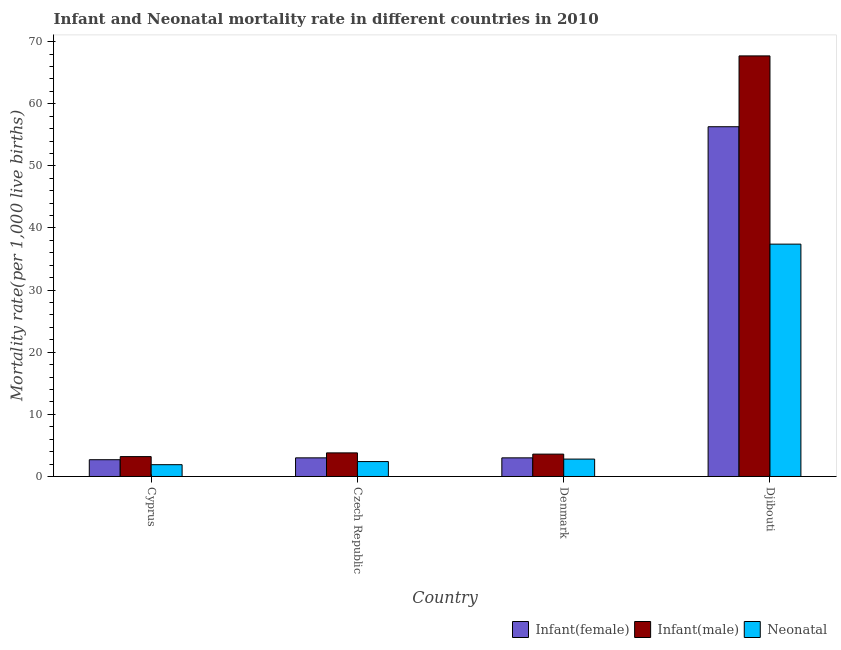How many different coloured bars are there?
Your answer should be very brief. 3. How many bars are there on the 3rd tick from the left?
Give a very brief answer. 3. How many bars are there on the 2nd tick from the right?
Offer a very short reply. 3. What is the label of the 1st group of bars from the left?
Provide a succinct answer. Cyprus. In how many cases, is the number of bars for a given country not equal to the number of legend labels?
Give a very brief answer. 0. What is the neonatal mortality rate in Djibouti?
Ensure brevity in your answer.  37.4. Across all countries, what is the maximum infant mortality rate(female)?
Offer a terse response. 56.3. Across all countries, what is the minimum infant mortality rate(female)?
Your answer should be compact. 2.7. In which country was the infant mortality rate(female) maximum?
Offer a very short reply. Djibouti. In which country was the infant mortality rate(female) minimum?
Your answer should be very brief. Cyprus. What is the total neonatal mortality rate in the graph?
Offer a terse response. 44.5. What is the difference between the neonatal mortality rate in Cyprus and that in Denmark?
Ensure brevity in your answer.  -0.9. What is the difference between the infant mortality rate(male) in Denmark and the neonatal mortality rate in Czech Republic?
Provide a short and direct response. 1.2. What is the average neonatal mortality rate per country?
Offer a terse response. 11.12. What is the difference between the infant mortality rate(female) and neonatal mortality rate in Djibouti?
Your response must be concise. 18.9. What is the ratio of the infant mortality rate(female) in Cyprus to that in Denmark?
Your answer should be compact. 0.9. Is the neonatal mortality rate in Czech Republic less than that in Denmark?
Offer a terse response. Yes. What is the difference between the highest and the second highest infant mortality rate(female)?
Give a very brief answer. 53.3. What is the difference between the highest and the lowest infant mortality rate(male)?
Your answer should be compact. 64.5. In how many countries, is the infant mortality rate(female) greater than the average infant mortality rate(female) taken over all countries?
Your answer should be compact. 1. What does the 1st bar from the left in Cyprus represents?
Provide a short and direct response. Infant(female). What does the 3rd bar from the right in Cyprus represents?
Your answer should be compact. Infant(female). How many bars are there?
Your answer should be compact. 12. What is the difference between two consecutive major ticks on the Y-axis?
Your response must be concise. 10. Are the values on the major ticks of Y-axis written in scientific E-notation?
Ensure brevity in your answer.  No. Does the graph contain any zero values?
Your answer should be compact. No. Where does the legend appear in the graph?
Your answer should be compact. Bottom right. What is the title of the graph?
Offer a terse response. Infant and Neonatal mortality rate in different countries in 2010. What is the label or title of the Y-axis?
Your answer should be compact. Mortality rate(per 1,0 live births). What is the Mortality rate(per 1,000 live births) of Infant(female) in Cyprus?
Offer a very short reply. 2.7. What is the Mortality rate(per 1,000 live births) in Infant(male) in Czech Republic?
Your answer should be very brief. 3.8. What is the Mortality rate(per 1,000 live births) of Infant(female) in Djibouti?
Keep it short and to the point. 56.3. What is the Mortality rate(per 1,000 live births) in Infant(male) in Djibouti?
Your response must be concise. 67.7. What is the Mortality rate(per 1,000 live births) in Neonatal  in Djibouti?
Keep it short and to the point. 37.4. Across all countries, what is the maximum Mortality rate(per 1,000 live births) in Infant(female)?
Make the answer very short. 56.3. Across all countries, what is the maximum Mortality rate(per 1,000 live births) of Infant(male)?
Make the answer very short. 67.7. Across all countries, what is the maximum Mortality rate(per 1,000 live births) of Neonatal ?
Your answer should be very brief. 37.4. Across all countries, what is the minimum Mortality rate(per 1,000 live births) of Infant(female)?
Provide a short and direct response. 2.7. Across all countries, what is the minimum Mortality rate(per 1,000 live births) of Infant(male)?
Your answer should be very brief. 3.2. Across all countries, what is the minimum Mortality rate(per 1,000 live births) in Neonatal ?
Keep it short and to the point. 1.9. What is the total Mortality rate(per 1,000 live births) in Infant(female) in the graph?
Give a very brief answer. 65. What is the total Mortality rate(per 1,000 live births) in Infant(male) in the graph?
Provide a short and direct response. 78.3. What is the total Mortality rate(per 1,000 live births) in Neonatal  in the graph?
Offer a terse response. 44.5. What is the difference between the Mortality rate(per 1,000 live births) in Neonatal  in Cyprus and that in Czech Republic?
Ensure brevity in your answer.  -0.5. What is the difference between the Mortality rate(per 1,000 live births) of Infant(female) in Cyprus and that in Djibouti?
Offer a terse response. -53.6. What is the difference between the Mortality rate(per 1,000 live births) of Infant(male) in Cyprus and that in Djibouti?
Your answer should be compact. -64.5. What is the difference between the Mortality rate(per 1,000 live births) in Neonatal  in Cyprus and that in Djibouti?
Ensure brevity in your answer.  -35.5. What is the difference between the Mortality rate(per 1,000 live births) in Infant(female) in Czech Republic and that in Denmark?
Your answer should be compact. 0. What is the difference between the Mortality rate(per 1,000 live births) in Infant(male) in Czech Republic and that in Denmark?
Provide a succinct answer. 0.2. What is the difference between the Mortality rate(per 1,000 live births) in Infant(female) in Czech Republic and that in Djibouti?
Provide a succinct answer. -53.3. What is the difference between the Mortality rate(per 1,000 live births) in Infant(male) in Czech Republic and that in Djibouti?
Offer a terse response. -63.9. What is the difference between the Mortality rate(per 1,000 live births) of Neonatal  in Czech Republic and that in Djibouti?
Provide a succinct answer. -35. What is the difference between the Mortality rate(per 1,000 live births) of Infant(female) in Denmark and that in Djibouti?
Ensure brevity in your answer.  -53.3. What is the difference between the Mortality rate(per 1,000 live births) in Infant(male) in Denmark and that in Djibouti?
Your answer should be very brief. -64.1. What is the difference between the Mortality rate(per 1,000 live births) of Neonatal  in Denmark and that in Djibouti?
Make the answer very short. -34.6. What is the difference between the Mortality rate(per 1,000 live births) of Infant(male) in Cyprus and the Mortality rate(per 1,000 live births) of Neonatal  in Czech Republic?
Your answer should be very brief. 0.8. What is the difference between the Mortality rate(per 1,000 live births) of Infant(female) in Cyprus and the Mortality rate(per 1,000 live births) of Infant(male) in Djibouti?
Keep it short and to the point. -65. What is the difference between the Mortality rate(per 1,000 live births) in Infant(female) in Cyprus and the Mortality rate(per 1,000 live births) in Neonatal  in Djibouti?
Provide a succinct answer. -34.7. What is the difference between the Mortality rate(per 1,000 live births) of Infant(male) in Cyprus and the Mortality rate(per 1,000 live births) of Neonatal  in Djibouti?
Your answer should be very brief. -34.2. What is the difference between the Mortality rate(per 1,000 live births) of Infant(female) in Czech Republic and the Mortality rate(per 1,000 live births) of Neonatal  in Denmark?
Make the answer very short. 0.2. What is the difference between the Mortality rate(per 1,000 live births) in Infant(male) in Czech Republic and the Mortality rate(per 1,000 live births) in Neonatal  in Denmark?
Give a very brief answer. 1. What is the difference between the Mortality rate(per 1,000 live births) in Infant(female) in Czech Republic and the Mortality rate(per 1,000 live births) in Infant(male) in Djibouti?
Ensure brevity in your answer.  -64.7. What is the difference between the Mortality rate(per 1,000 live births) of Infant(female) in Czech Republic and the Mortality rate(per 1,000 live births) of Neonatal  in Djibouti?
Provide a short and direct response. -34.4. What is the difference between the Mortality rate(per 1,000 live births) of Infant(male) in Czech Republic and the Mortality rate(per 1,000 live births) of Neonatal  in Djibouti?
Your answer should be very brief. -33.6. What is the difference between the Mortality rate(per 1,000 live births) of Infant(female) in Denmark and the Mortality rate(per 1,000 live births) of Infant(male) in Djibouti?
Ensure brevity in your answer.  -64.7. What is the difference between the Mortality rate(per 1,000 live births) in Infant(female) in Denmark and the Mortality rate(per 1,000 live births) in Neonatal  in Djibouti?
Make the answer very short. -34.4. What is the difference between the Mortality rate(per 1,000 live births) in Infant(male) in Denmark and the Mortality rate(per 1,000 live births) in Neonatal  in Djibouti?
Your answer should be very brief. -33.8. What is the average Mortality rate(per 1,000 live births) in Infant(female) per country?
Make the answer very short. 16.25. What is the average Mortality rate(per 1,000 live births) of Infant(male) per country?
Offer a terse response. 19.57. What is the average Mortality rate(per 1,000 live births) in Neonatal  per country?
Give a very brief answer. 11.12. What is the difference between the Mortality rate(per 1,000 live births) of Infant(male) and Mortality rate(per 1,000 live births) of Neonatal  in Cyprus?
Offer a very short reply. 1.3. What is the difference between the Mortality rate(per 1,000 live births) in Infant(female) and Mortality rate(per 1,000 live births) in Infant(male) in Czech Republic?
Offer a terse response. -0.8. What is the difference between the Mortality rate(per 1,000 live births) of Infant(female) and Mortality rate(per 1,000 live births) of Infant(male) in Denmark?
Ensure brevity in your answer.  -0.6. What is the difference between the Mortality rate(per 1,000 live births) of Infant(male) and Mortality rate(per 1,000 live births) of Neonatal  in Denmark?
Offer a very short reply. 0.8. What is the difference between the Mortality rate(per 1,000 live births) of Infant(female) and Mortality rate(per 1,000 live births) of Infant(male) in Djibouti?
Your answer should be compact. -11.4. What is the difference between the Mortality rate(per 1,000 live births) of Infant(male) and Mortality rate(per 1,000 live births) of Neonatal  in Djibouti?
Offer a very short reply. 30.3. What is the ratio of the Mortality rate(per 1,000 live births) of Infant(female) in Cyprus to that in Czech Republic?
Provide a succinct answer. 0.9. What is the ratio of the Mortality rate(per 1,000 live births) of Infant(male) in Cyprus to that in Czech Republic?
Keep it short and to the point. 0.84. What is the ratio of the Mortality rate(per 1,000 live births) in Neonatal  in Cyprus to that in Czech Republic?
Offer a very short reply. 0.79. What is the ratio of the Mortality rate(per 1,000 live births) in Infant(female) in Cyprus to that in Denmark?
Provide a short and direct response. 0.9. What is the ratio of the Mortality rate(per 1,000 live births) in Neonatal  in Cyprus to that in Denmark?
Offer a very short reply. 0.68. What is the ratio of the Mortality rate(per 1,000 live births) of Infant(female) in Cyprus to that in Djibouti?
Provide a succinct answer. 0.05. What is the ratio of the Mortality rate(per 1,000 live births) in Infant(male) in Cyprus to that in Djibouti?
Provide a short and direct response. 0.05. What is the ratio of the Mortality rate(per 1,000 live births) of Neonatal  in Cyprus to that in Djibouti?
Make the answer very short. 0.05. What is the ratio of the Mortality rate(per 1,000 live births) in Infant(female) in Czech Republic to that in Denmark?
Offer a very short reply. 1. What is the ratio of the Mortality rate(per 1,000 live births) of Infant(male) in Czech Republic to that in Denmark?
Give a very brief answer. 1.06. What is the ratio of the Mortality rate(per 1,000 live births) in Neonatal  in Czech Republic to that in Denmark?
Provide a short and direct response. 0.86. What is the ratio of the Mortality rate(per 1,000 live births) in Infant(female) in Czech Republic to that in Djibouti?
Offer a terse response. 0.05. What is the ratio of the Mortality rate(per 1,000 live births) in Infant(male) in Czech Republic to that in Djibouti?
Offer a very short reply. 0.06. What is the ratio of the Mortality rate(per 1,000 live births) of Neonatal  in Czech Republic to that in Djibouti?
Your answer should be very brief. 0.06. What is the ratio of the Mortality rate(per 1,000 live births) of Infant(female) in Denmark to that in Djibouti?
Offer a very short reply. 0.05. What is the ratio of the Mortality rate(per 1,000 live births) in Infant(male) in Denmark to that in Djibouti?
Provide a short and direct response. 0.05. What is the ratio of the Mortality rate(per 1,000 live births) in Neonatal  in Denmark to that in Djibouti?
Keep it short and to the point. 0.07. What is the difference between the highest and the second highest Mortality rate(per 1,000 live births) of Infant(female)?
Ensure brevity in your answer.  53.3. What is the difference between the highest and the second highest Mortality rate(per 1,000 live births) of Infant(male)?
Offer a terse response. 63.9. What is the difference between the highest and the second highest Mortality rate(per 1,000 live births) in Neonatal ?
Your response must be concise. 34.6. What is the difference between the highest and the lowest Mortality rate(per 1,000 live births) of Infant(female)?
Provide a short and direct response. 53.6. What is the difference between the highest and the lowest Mortality rate(per 1,000 live births) in Infant(male)?
Keep it short and to the point. 64.5. What is the difference between the highest and the lowest Mortality rate(per 1,000 live births) of Neonatal ?
Ensure brevity in your answer.  35.5. 